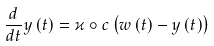Convert formula to latex. <formula><loc_0><loc_0><loc_500><loc_500>\frac { d } { d t } y \left ( t \right ) = \varkappa \circ c \left ( w \left ( t \right ) - y \left ( t \right ) \right )</formula> 